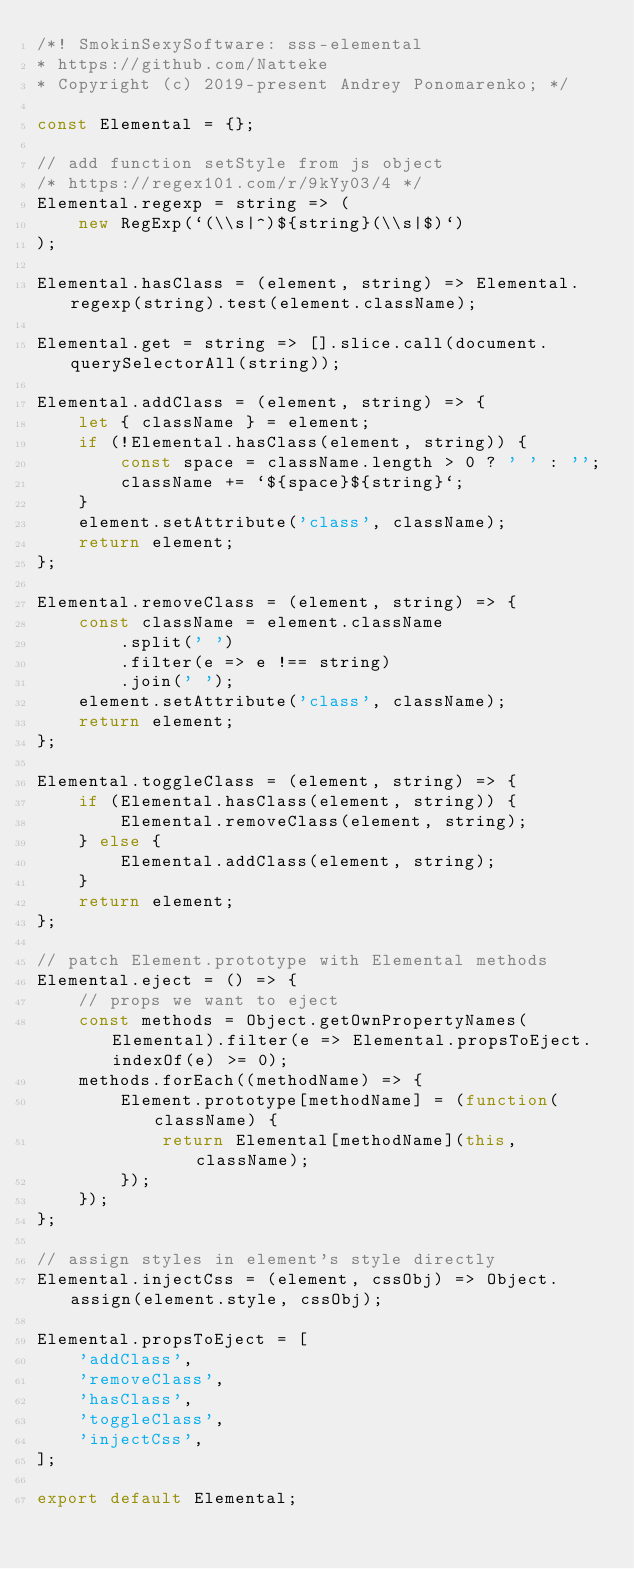<code> <loc_0><loc_0><loc_500><loc_500><_JavaScript_>/*! SmokinSexySoftware: sss-elemental
* https://github.com/Natteke
* Copyright (c) 2019-present Andrey Ponomarenko; */

const Elemental = {};

// add function setStyle from js object
/* https://regex101.com/r/9kYy03/4 */
Elemental.regexp = string => (
    new RegExp(`(\\s|^)${string}(\\s|$)`)
);

Elemental.hasClass = (element, string) => Elemental.regexp(string).test(element.className);

Elemental.get = string => [].slice.call(document.querySelectorAll(string));

Elemental.addClass = (element, string) => {
    let { className } = element;
    if (!Elemental.hasClass(element, string)) {
        const space = className.length > 0 ? ' ' : '';
        className += `${space}${string}`;
    }
    element.setAttribute('class', className);
    return element;
};

Elemental.removeClass = (element, string) => {
    const className = element.className
        .split(' ')
        .filter(e => e !== string)
        .join(' ');
    element.setAttribute('class', className);
    return element;
};

Elemental.toggleClass = (element, string) => {
    if (Elemental.hasClass(element, string)) {
        Elemental.removeClass(element, string);
    } else {
        Elemental.addClass(element, string);
    }
    return element;
};

// patch Element.prototype with Elemental methods
Elemental.eject = () => {
    // props we want to eject
    const methods = Object.getOwnPropertyNames(Elemental).filter(e => Elemental.propsToEject.indexOf(e) >= 0);
    methods.forEach((methodName) => {
        Element.prototype[methodName] = (function(className) {
            return Elemental[methodName](this, className);
        });
    });
};

// assign styles in element's style directly
Elemental.injectCss = (element, cssObj) => Object.assign(element.style, cssObj);

Elemental.propsToEject = [
    'addClass',
    'removeClass',
    'hasClass',
    'toggleClass',
    'injectCss',
];

export default Elemental;
</code> 